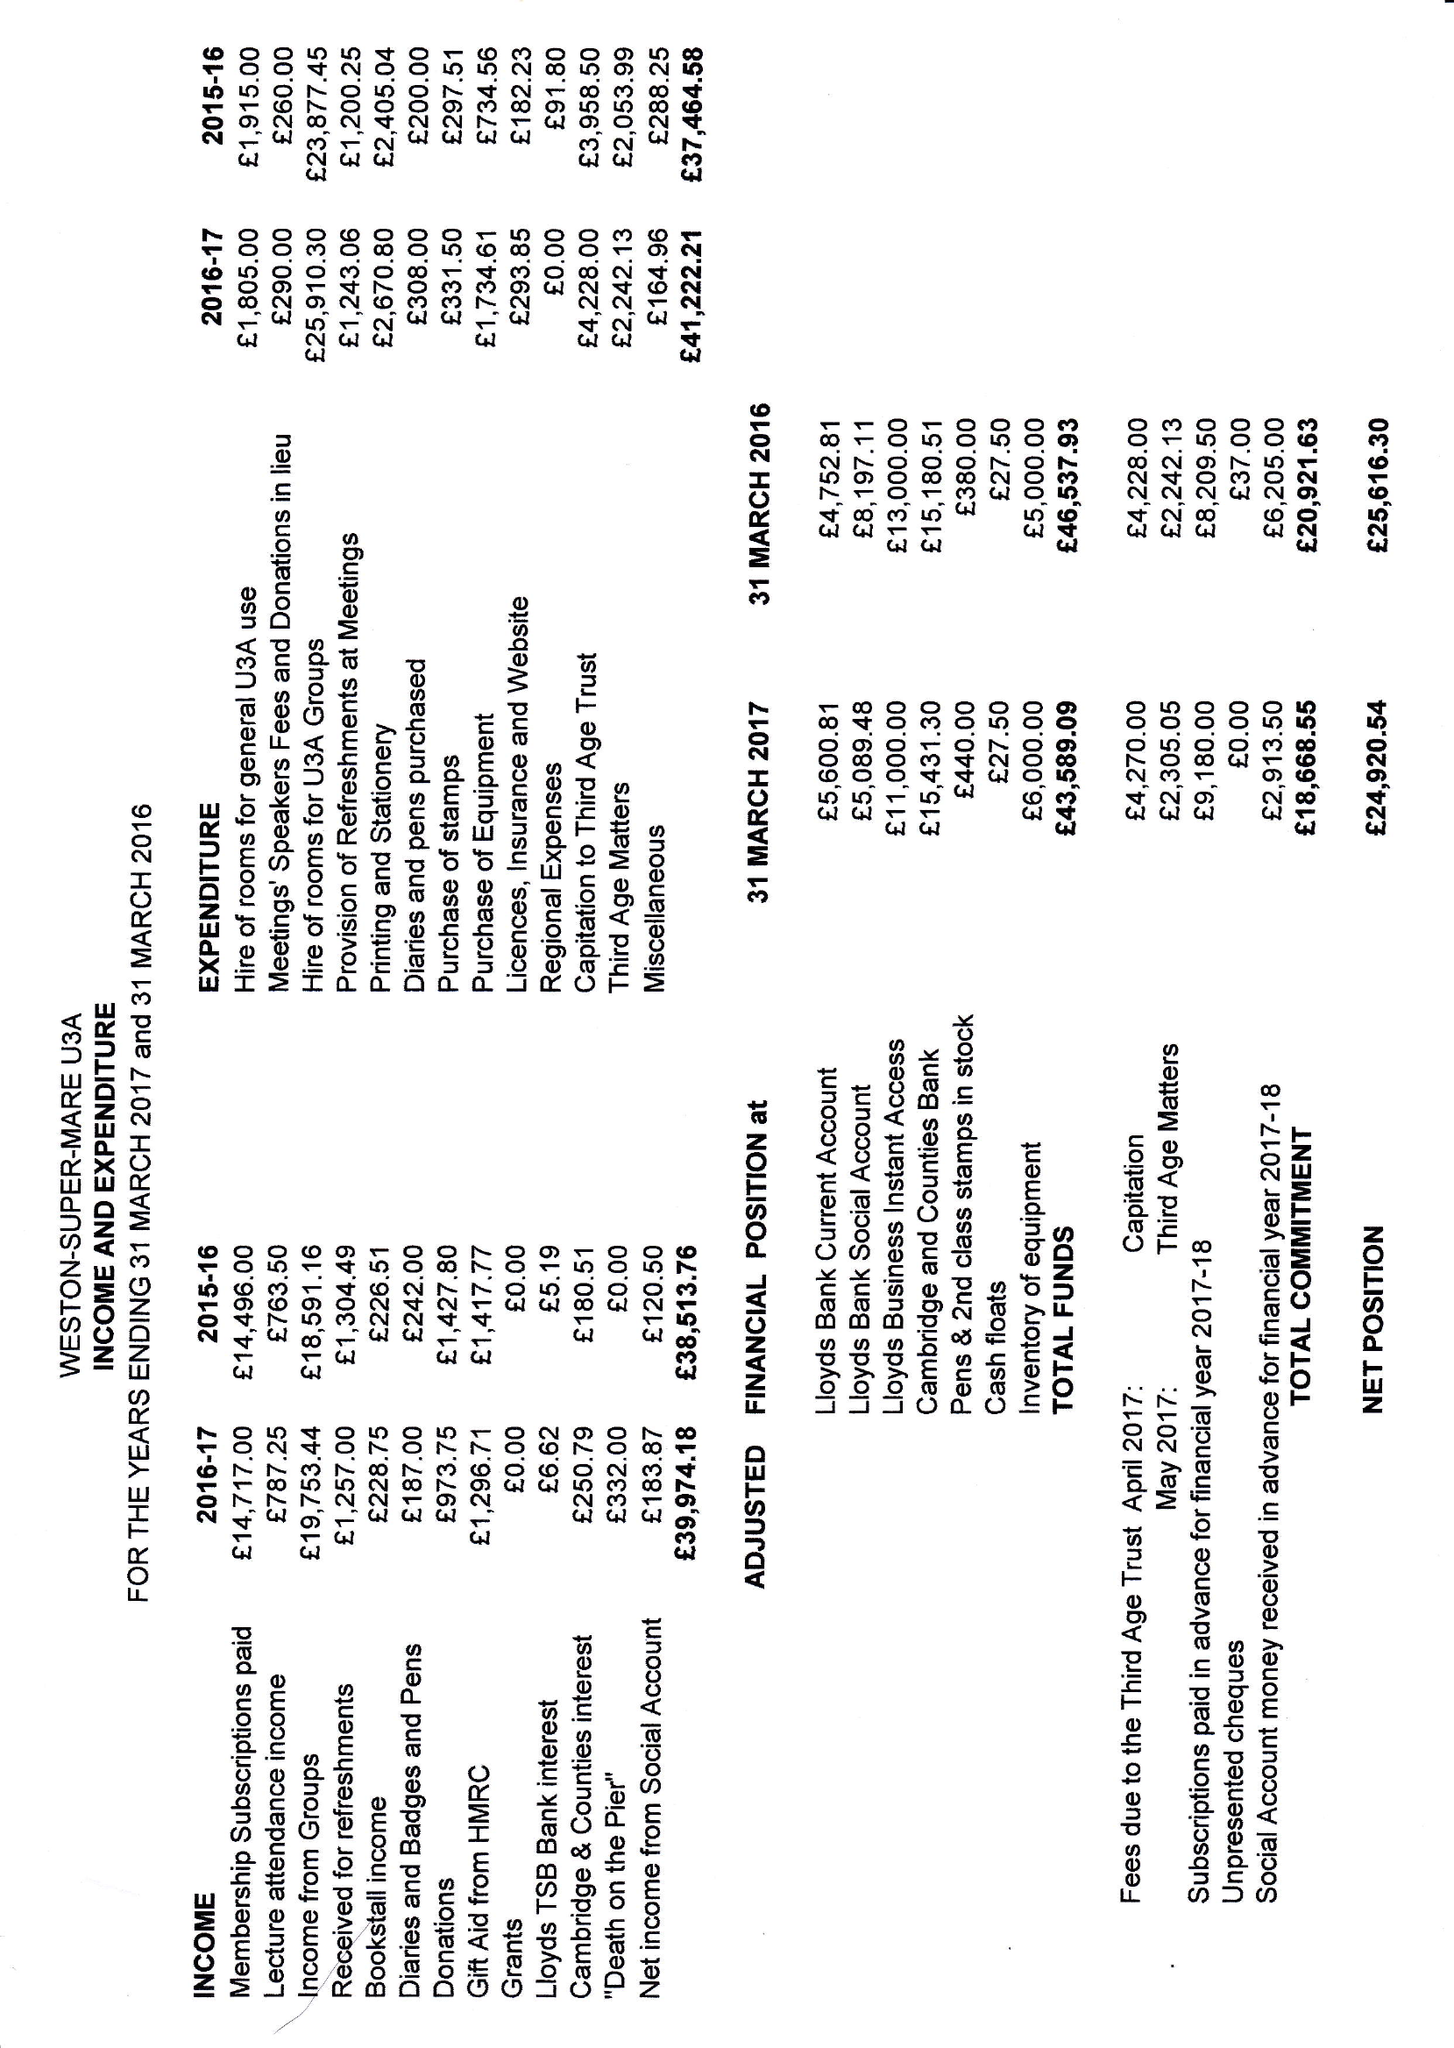What is the value for the address__street_line?
Answer the question using a single word or phrase. 3 WIGMORE GARDENS 